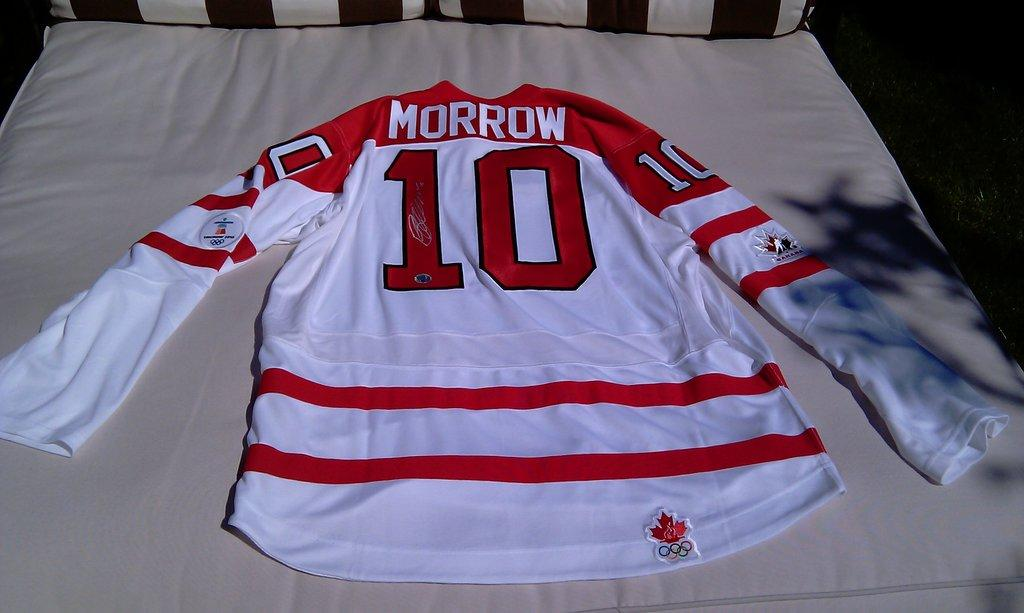<image>
Create a compact narrative representing the image presented. a Morrow number 10 jersey is laying on the bed 